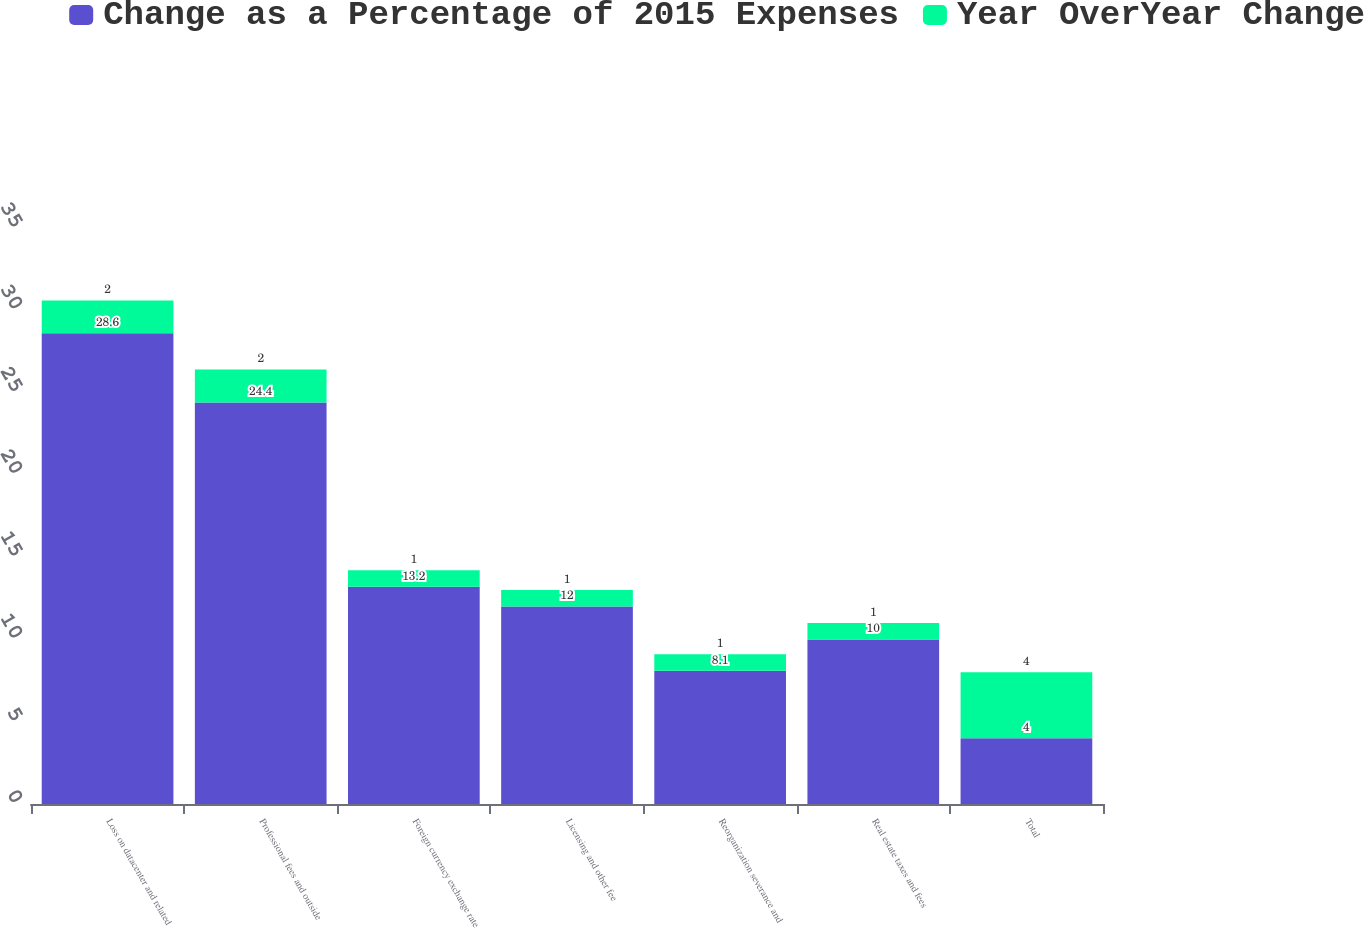Convert chart to OTSL. <chart><loc_0><loc_0><loc_500><loc_500><stacked_bar_chart><ecel><fcel>Loss on datacenter and related<fcel>Professional fees and outside<fcel>Foreign currency exchange rate<fcel>Licensing and other fee<fcel>Reorganization severance and<fcel>Real estate taxes and fees<fcel>Total<nl><fcel>Change as a Percentage of 2015 Expenses<fcel>28.6<fcel>24.4<fcel>13.2<fcel>12<fcel>8.1<fcel>10<fcel>4<nl><fcel>Year OverYear Change<fcel>2<fcel>2<fcel>1<fcel>1<fcel>1<fcel>1<fcel>4<nl></chart> 